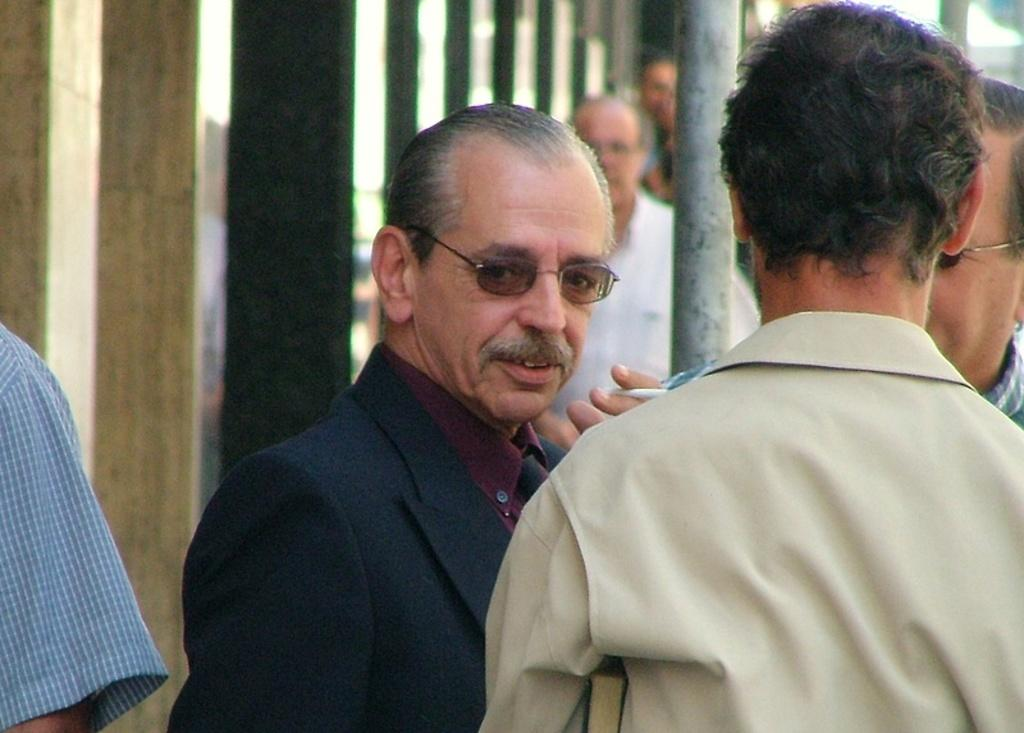How many men are in the image? There are men in the image, but the exact number is not specified. What is one of the men wearing? One of the men is wearing a coat. What accessory is worn by another man in the image? One of the men is wearing spectacles. What can be seen on the right side of the image? There is a pole on the right side of the image. Can you tell me how many snails are crawling on the pole in the image? There are no snails present in the image; the pole is the only object mentioned on the right side. 